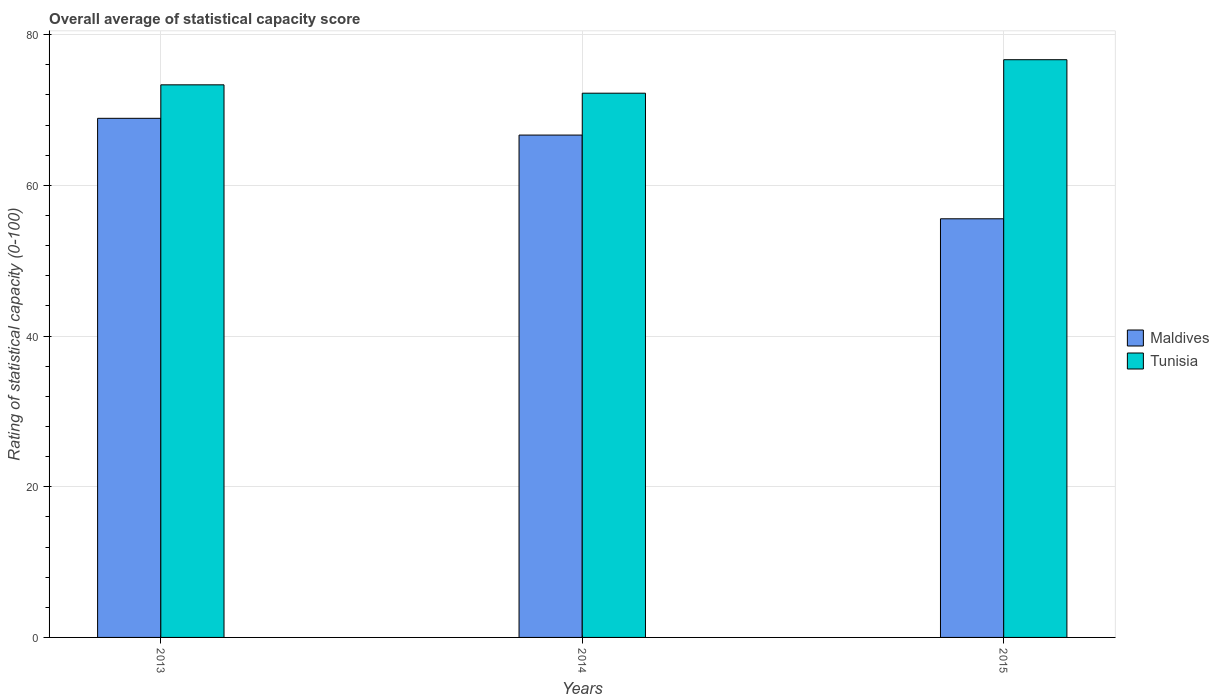Are the number of bars per tick equal to the number of legend labels?
Provide a succinct answer. Yes. How many bars are there on the 1st tick from the right?
Keep it short and to the point. 2. What is the label of the 3rd group of bars from the left?
Ensure brevity in your answer.  2015. What is the rating of statistical capacity in Tunisia in 2014?
Your response must be concise. 72.22. Across all years, what is the maximum rating of statistical capacity in Maldives?
Keep it short and to the point. 68.89. Across all years, what is the minimum rating of statistical capacity in Tunisia?
Offer a terse response. 72.22. In which year was the rating of statistical capacity in Tunisia minimum?
Ensure brevity in your answer.  2014. What is the total rating of statistical capacity in Tunisia in the graph?
Your answer should be compact. 222.22. What is the difference between the rating of statistical capacity in Tunisia in 2013 and that in 2015?
Your response must be concise. -3.33. What is the difference between the rating of statistical capacity in Tunisia in 2015 and the rating of statistical capacity in Maldives in 2013?
Keep it short and to the point. 7.78. What is the average rating of statistical capacity in Maldives per year?
Your answer should be very brief. 63.7. In the year 2014, what is the difference between the rating of statistical capacity in Maldives and rating of statistical capacity in Tunisia?
Provide a succinct answer. -5.56. What is the ratio of the rating of statistical capacity in Maldives in 2013 to that in 2015?
Keep it short and to the point. 1.24. What is the difference between the highest and the second highest rating of statistical capacity in Tunisia?
Your response must be concise. 3.33. What is the difference between the highest and the lowest rating of statistical capacity in Tunisia?
Your response must be concise. 4.44. In how many years, is the rating of statistical capacity in Maldives greater than the average rating of statistical capacity in Maldives taken over all years?
Your answer should be compact. 2. Is the sum of the rating of statistical capacity in Maldives in 2013 and 2014 greater than the maximum rating of statistical capacity in Tunisia across all years?
Make the answer very short. Yes. What does the 2nd bar from the left in 2013 represents?
Your response must be concise. Tunisia. What does the 1st bar from the right in 2015 represents?
Provide a short and direct response. Tunisia. How many bars are there?
Ensure brevity in your answer.  6. Are all the bars in the graph horizontal?
Your answer should be compact. No. Are the values on the major ticks of Y-axis written in scientific E-notation?
Make the answer very short. No. Does the graph contain any zero values?
Make the answer very short. No. What is the title of the graph?
Your response must be concise. Overall average of statistical capacity score. What is the label or title of the Y-axis?
Provide a succinct answer. Rating of statistical capacity (0-100). What is the Rating of statistical capacity (0-100) of Maldives in 2013?
Give a very brief answer. 68.89. What is the Rating of statistical capacity (0-100) of Tunisia in 2013?
Provide a short and direct response. 73.33. What is the Rating of statistical capacity (0-100) in Maldives in 2014?
Make the answer very short. 66.67. What is the Rating of statistical capacity (0-100) in Tunisia in 2014?
Your response must be concise. 72.22. What is the Rating of statistical capacity (0-100) in Maldives in 2015?
Keep it short and to the point. 55.56. What is the Rating of statistical capacity (0-100) of Tunisia in 2015?
Make the answer very short. 76.67. Across all years, what is the maximum Rating of statistical capacity (0-100) in Maldives?
Your response must be concise. 68.89. Across all years, what is the maximum Rating of statistical capacity (0-100) in Tunisia?
Offer a terse response. 76.67. Across all years, what is the minimum Rating of statistical capacity (0-100) of Maldives?
Make the answer very short. 55.56. Across all years, what is the minimum Rating of statistical capacity (0-100) in Tunisia?
Your response must be concise. 72.22. What is the total Rating of statistical capacity (0-100) of Maldives in the graph?
Your answer should be very brief. 191.11. What is the total Rating of statistical capacity (0-100) in Tunisia in the graph?
Your response must be concise. 222.22. What is the difference between the Rating of statistical capacity (0-100) of Maldives in 2013 and that in 2014?
Ensure brevity in your answer.  2.22. What is the difference between the Rating of statistical capacity (0-100) of Maldives in 2013 and that in 2015?
Make the answer very short. 13.33. What is the difference between the Rating of statistical capacity (0-100) in Tunisia in 2013 and that in 2015?
Provide a succinct answer. -3.33. What is the difference between the Rating of statistical capacity (0-100) of Maldives in 2014 and that in 2015?
Provide a short and direct response. 11.11. What is the difference between the Rating of statistical capacity (0-100) in Tunisia in 2014 and that in 2015?
Offer a terse response. -4.44. What is the difference between the Rating of statistical capacity (0-100) of Maldives in 2013 and the Rating of statistical capacity (0-100) of Tunisia in 2014?
Make the answer very short. -3.33. What is the difference between the Rating of statistical capacity (0-100) of Maldives in 2013 and the Rating of statistical capacity (0-100) of Tunisia in 2015?
Offer a terse response. -7.78. What is the difference between the Rating of statistical capacity (0-100) in Maldives in 2014 and the Rating of statistical capacity (0-100) in Tunisia in 2015?
Provide a succinct answer. -10. What is the average Rating of statistical capacity (0-100) in Maldives per year?
Make the answer very short. 63.7. What is the average Rating of statistical capacity (0-100) of Tunisia per year?
Your response must be concise. 74.07. In the year 2013, what is the difference between the Rating of statistical capacity (0-100) of Maldives and Rating of statistical capacity (0-100) of Tunisia?
Make the answer very short. -4.44. In the year 2014, what is the difference between the Rating of statistical capacity (0-100) of Maldives and Rating of statistical capacity (0-100) of Tunisia?
Offer a terse response. -5.56. In the year 2015, what is the difference between the Rating of statistical capacity (0-100) of Maldives and Rating of statistical capacity (0-100) of Tunisia?
Offer a terse response. -21.11. What is the ratio of the Rating of statistical capacity (0-100) of Maldives in 2013 to that in 2014?
Your response must be concise. 1.03. What is the ratio of the Rating of statistical capacity (0-100) of Tunisia in 2013 to that in 2014?
Give a very brief answer. 1.02. What is the ratio of the Rating of statistical capacity (0-100) in Maldives in 2013 to that in 2015?
Keep it short and to the point. 1.24. What is the ratio of the Rating of statistical capacity (0-100) in Tunisia in 2013 to that in 2015?
Make the answer very short. 0.96. What is the ratio of the Rating of statistical capacity (0-100) of Tunisia in 2014 to that in 2015?
Ensure brevity in your answer.  0.94. What is the difference between the highest and the second highest Rating of statistical capacity (0-100) in Maldives?
Offer a very short reply. 2.22. What is the difference between the highest and the second highest Rating of statistical capacity (0-100) in Tunisia?
Give a very brief answer. 3.33. What is the difference between the highest and the lowest Rating of statistical capacity (0-100) in Maldives?
Your answer should be very brief. 13.33. What is the difference between the highest and the lowest Rating of statistical capacity (0-100) in Tunisia?
Offer a terse response. 4.44. 